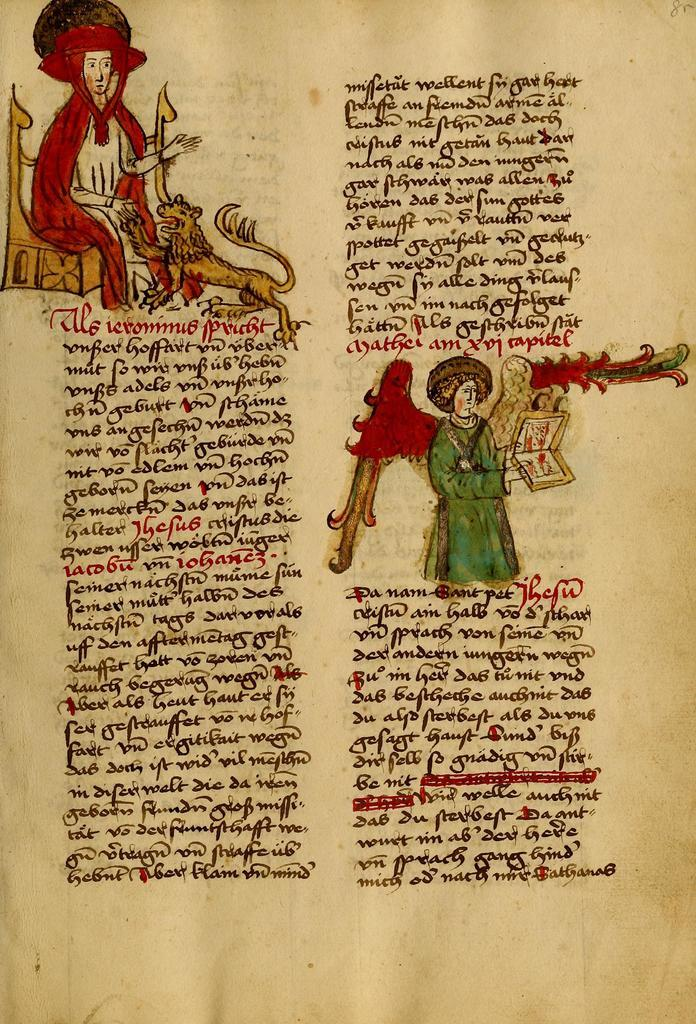What is featured in the image? There is a poster in the image. Are there any other subjects or objects visible in the image? Yes, there are people visible in the image. What can be found on the poster? There is text on the poster. What type of pain is being expressed by the people in the image? There is no indication of pain in the image; the people are not shown expressing any emotions or physical discomfort. 